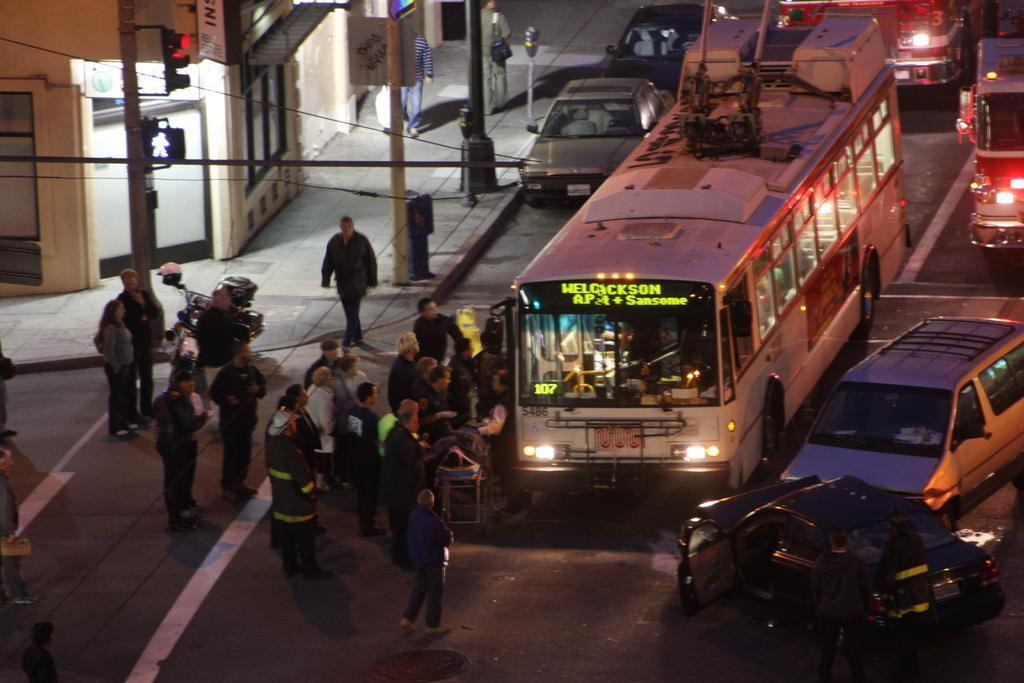Can you describe this image briefly? In this image we can see some vehicles on the road, there are some poles, lights, people, windows, doors and boards with some text, also we can see a building. 